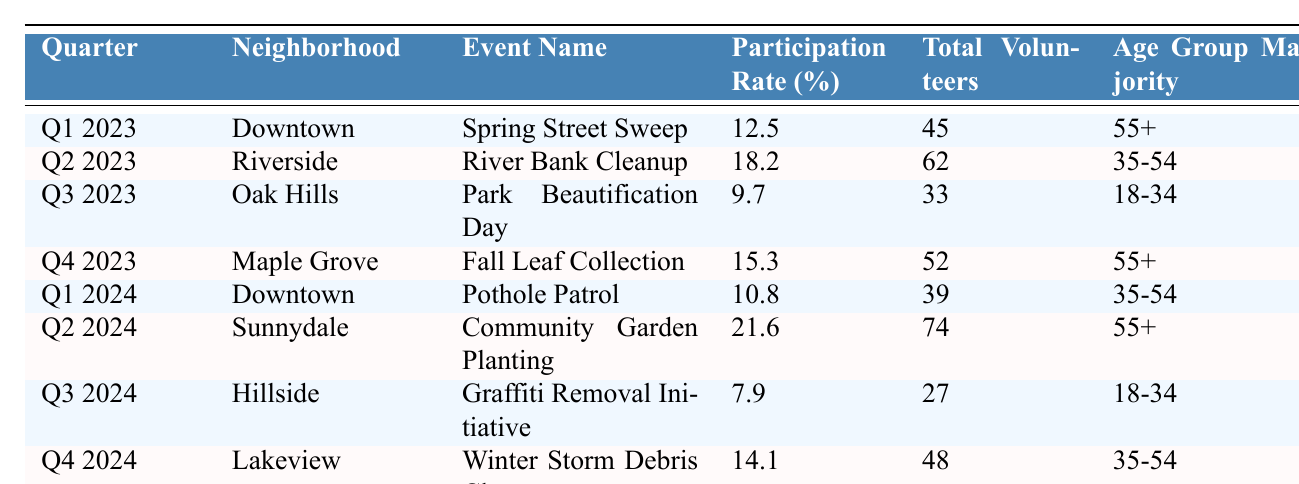What was the highest participation rate in the table? The table shows various participation rates across different events. Scanning through the participation rate column, the highest rate noted is 21.6% for the event "Community Garden Planting" in Q2 2024.
Answer: 21.6% Which neighborhood had the lowest total volunteers in 2023? By checking the total volunteers for each event in 2023, I find that "Park Beautification Day" in Oak Hills had the lowest number at 33 volunteers compared to other neighborhoods.
Answer: Oak Hills What is the average participation rate for all neighborhood clean-up events in Q1? There are two events in Q1: "Spring Street Sweep" with a 12.5% participation rate and "Pothole Patrol" with a 10.8% participation rate. Adding these gives 12.5 + 10.8 = 23.3%. Dividing this total by 2 gives an average participation rate of 23.3 / 2 = 11.65%.
Answer: 11.65% Is the majority age group for the Riverside event 55+? The table lists the age group majority for the Riverside event as 35-54. Therefore, it is not true that the majority age group is 55+.
Answer: No How does the participation rate for Q2 2024 compare to Q2 2023? The participation rate for Q2 2023 is 18.2%, while for Q2 2024, it is 21.6%. The difference is 21.6 - 18.2 = 3.4%, which indicates an increase from the previous year.
Answer: Increased by 3.4% What percentage of total volunteers participated in the Oak Hills event? The total volunteers for the Oak Hills event (Park Beautification Day) is 33, and the participation rate is 9.7%. This means roughly 3.2 volunteers participated (because 9.7% of 33 is about 3.2). This indicates that the volunteer response to this event was relatively low.
Answer: 3.2 volunteers What was the trend in participation rates from Q3 2023 to Q4 2024? Looking at the participation rates, Q3 2023 shows a rate of 9.7%, while Q4 2024 shows a rate of 14.1%. This indicates an overall improvement in participation rates over this period, moving from 9.7% to 14.1%.
Answer: Improvement Which neighborhood had more participation, Sunnydale or Lakeview? The participation rate for Sunnydale in Q2 2024 is 21.6%, while Lakeview in Q4 2024 has a participation rate of 14.1%. Therefore, Sunnydale had more participation.
Answer: Sunnydale What is the difference in total volunteers between the highest and lowest participation rates? The event with the highest participation rate (21.6% in Sunnydale) had 74 volunteers, and the event with the lowest participation rate (7.9% for Hillside) had 27 volunteers. The difference in total volunteers is 74 - 27 = 47.
Answer: 47 volunteers Was the majority age group for events in Q4 2023 35-54? Both Q4 2023 events had a majority age group of 55+, not 35-54. Thus, it is false to claim the majority age group was 35-54.
Answer: No How many neighborhoods are represented in the table for Q2 2023 and Q2 2024 combined? The neighborhoods represented are Riverside (Q2 2023) and Sunnydale (Q2 2024). Thus, there are 2 unique neighborhoods for these quarters.
Answer: 2 neighborhoods 